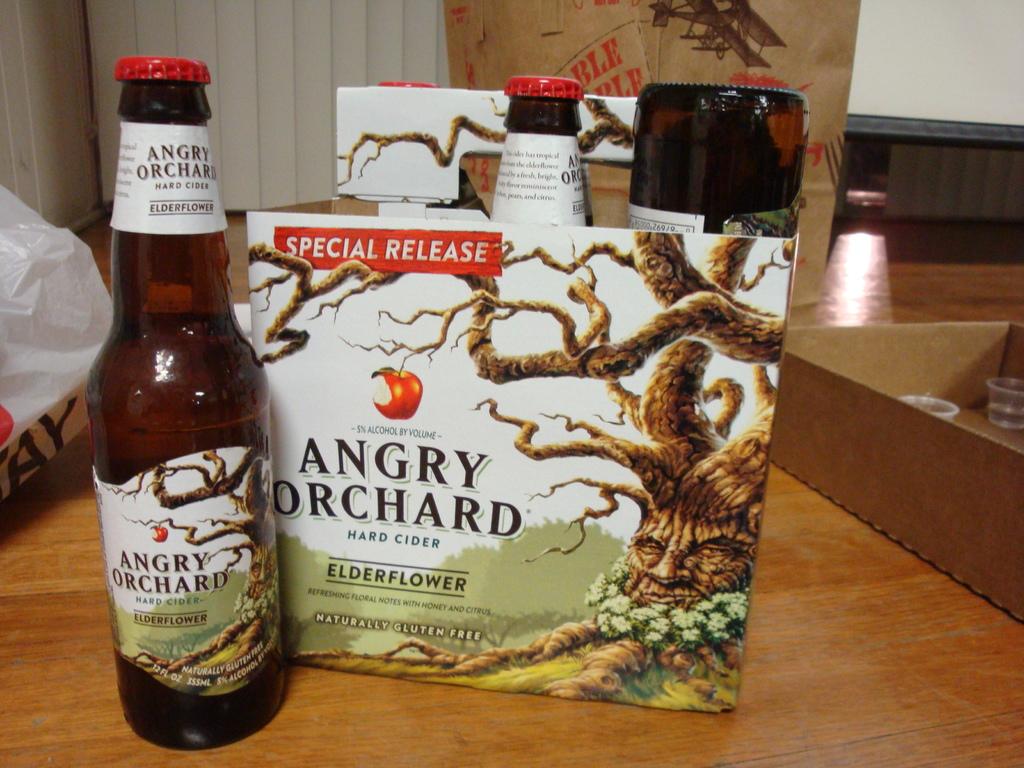What kind of release is this?
Ensure brevity in your answer.  Special. 